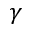<formula> <loc_0><loc_0><loc_500><loc_500>\gamma</formula> 